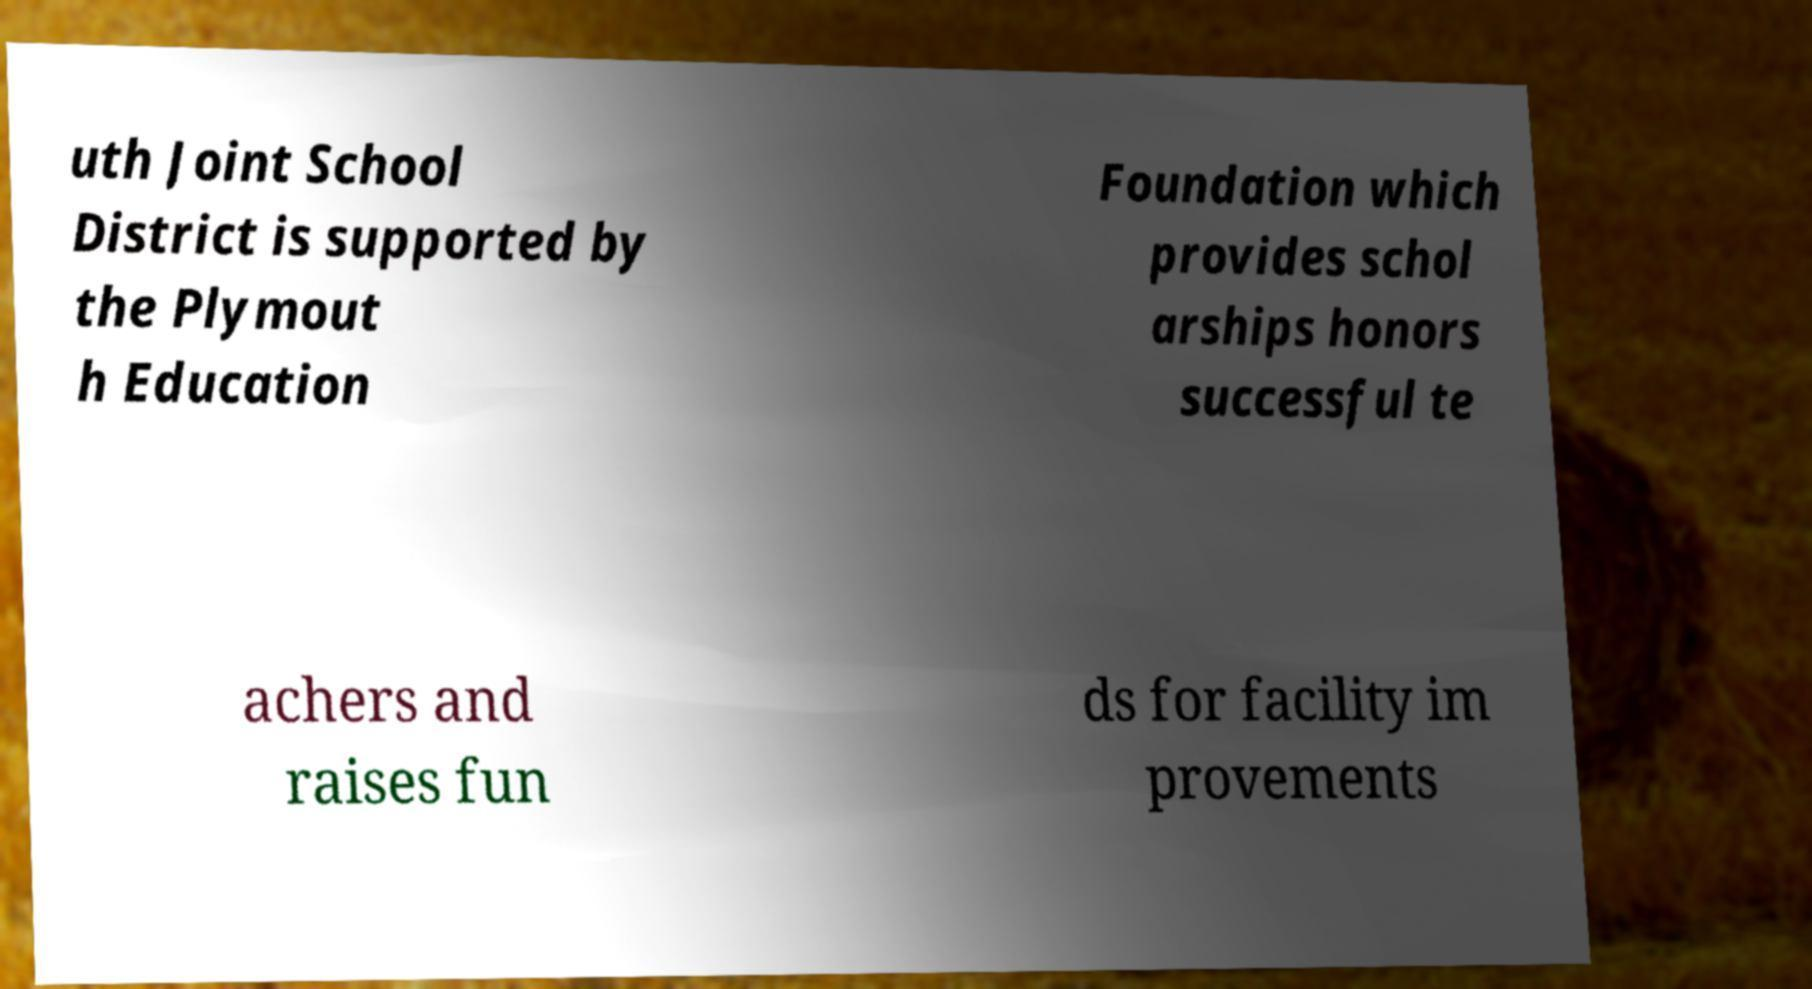For documentation purposes, I need the text within this image transcribed. Could you provide that? uth Joint School District is supported by the Plymout h Education Foundation which provides schol arships honors successful te achers and raises fun ds for facility im provements 